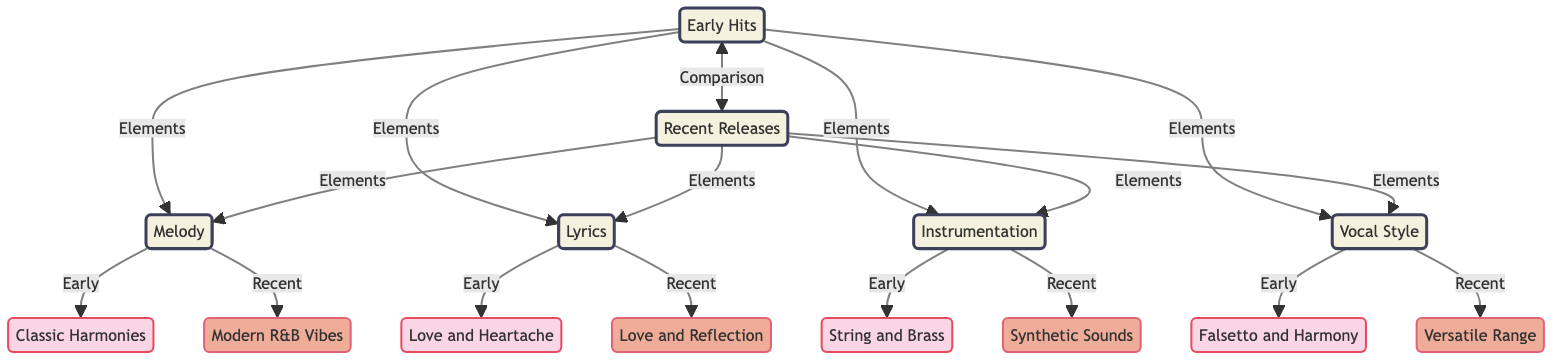What are the elements associated with early hits? The elements associated with early hits include melody, lyrics, instrumentation, and vocal style. These are directly linked to the "Early Hits" node in the diagram.
Answer: melody, lyrics, instrumentation, vocal style What is the vocal style of recent releases? The vocal style of recent releases is labeled as "Versatile Range" in the diagram, which is connected to the "Vocal Style" element for recent releases.
Answer: Versatile Range How many elements are connected to early hits? The "Early Hits" node has four elements connected to it: melody, lyrics, instrumentation, and vocal style. Counting these gives us a total of four.
Answer: 4 What type of instrumentation do recent releases use? The instrumentation for recent releases is categorized as "Synthetic Sounds," which is linked under the instrumentation element for recent releases in the diagram.
Answer: Synthetic Sounds What is the comparison made in the diagram? The comparison made in the diagram is between "Early Hits" and "Recent Releases," as indicated by the horizontal connection labeled "Comparison."
Answer: Early Hits and Recent Releases What melody shift is indicated in the diagram from early to recent releases? The diagram indicates that the melody has shifted from "Classic Harmonies" in early hits to "Modern R&B Vibes" in recent releases. This transition is observed in the respective nodes under the melody element.
Answer: Classic Harmonies to Modern R&B Vibes Which lyrical theme has evolved from early hits to recent releases? The lyrical theme has evolved from "Love and Heartache" in early hits to "Love and Reflection" in recent releases. This is detailed in the diagram under the lyrics section.
Answer: Love and Heartache to Love and Reflection What type of sound was primarily used in early instrumentation? The diagram specifies that early instrumentation primarily used "String and Brass," which is linked under the instrumentation element for early hits.
Answer: String and Brass Which visual element distinguishes early hits from recent releases? The visual element that distinguishes early hits from recent releases is the color coding: early hits are represented in pink shades while recent releases are in orange shades.
Answer: Color coding: pink (early) and orange (recent) 